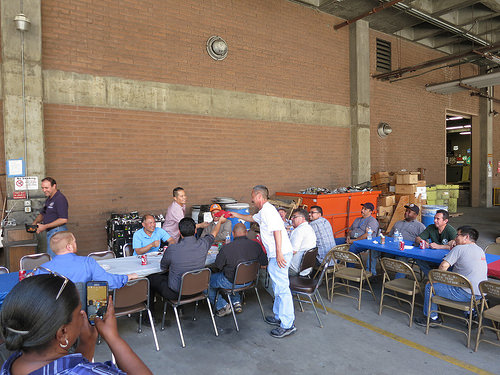<image>
Is the table on the chair? Yes. Looking at the image, I can see the table is positioned on top of the chair, with the chair providing support. 